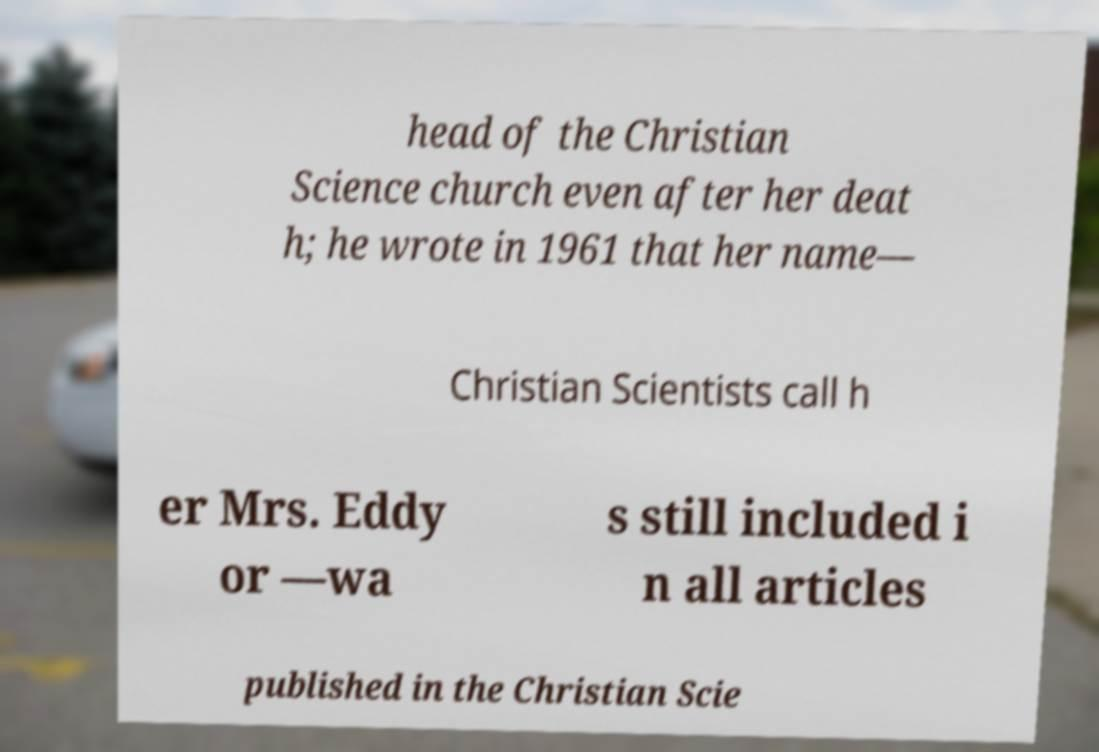Could you assist in decoding the text presented in this image and type it out clearly? head of the Christian Science church even after her deat h; he wrote in 1961 that her name— Christian Scientists call h er Mrs. Eddy or —wa s still included i n all articles published in the Christian Scie 